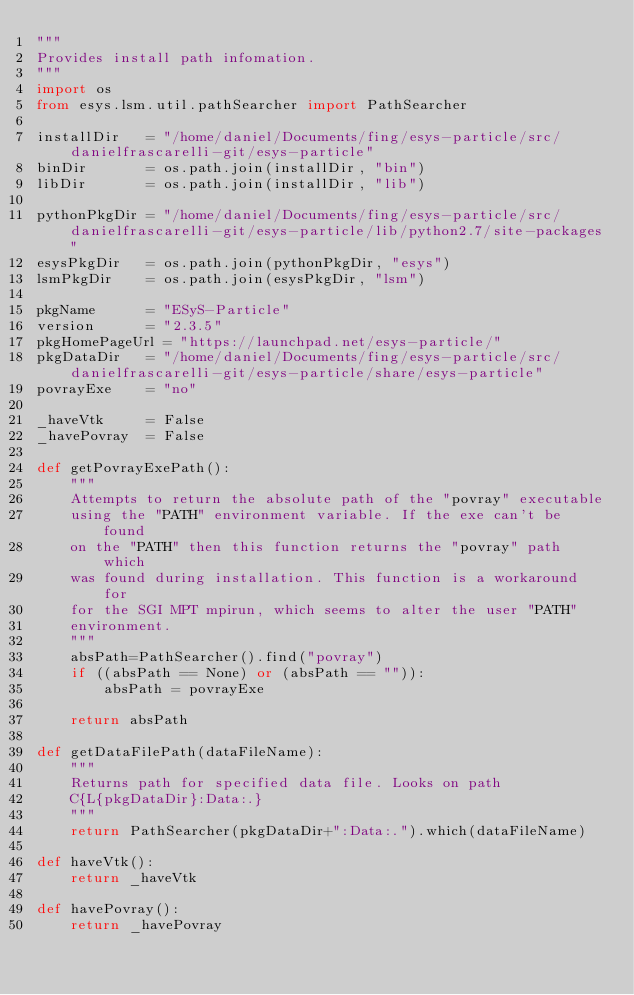<code> <loc_0><loc_0><loc_500><loc_500><_Python_>"""
Provides install path infomation.
"""
import os
from esys.lsm.util.pathSearcher import PathSearcher

installDir   = "/home/daniel/Documents/fing/esys-particle/src/danielfrascarelli-git/esys-particle"
binDir       = os.path.join(installDir, "bin")
libDir       = os.path.join(installDir, "lib")

pythonPkgDir = "/home/daniel/Documents/fing/esys-particle/src/danielfrascarelli-git/esys-particle/lib/python2.7/site-packages"
esysPkgDir   = os.path.join(pythonPkgDir, "esys")
lsmPkgDir    = os.path.join(esysPkgDir, "lsm")

pkgName      = "ESyS-Particle"
version      = "2.3.5"
pkgHomePageUrl = "https://launchpad.net/esys-particle/"
pkgDataDir   = "/home/daniel/Documents/fing/esys-particle/src/danielfrascarelli-git/esys-particle/share/esys-particle"
povrayExe    = "no"

_haveVtk     = False
_havePovray  = False

def getPovrayExePath():
    """
    Attempts to return the absolute path of the "povray" executable
    using the "PATH" environment variable. If the exe can't be found
    on the "PATH" then this function returns the "povray" path which
    was found during installation. This function is a workaround for
    for the SGI MPT mpirun, which seems to alter the user "PATH"
    environment.
    """
    absPath=PathSearcher().find("povray")
    if ((absPath == None) or (absPath == "")):
        absPath = povrayExe

    return absPath

def getDataFilePath(dataFileName):
    """
    Returns path for specified data file. Looks on path
    C{L{pkgDataDir}:Data:.}
    """
    return PathSearcher(pkgDataDir+":Data:.").which(dataFileName)

def haveVtk():
    return _haveVtk

def havePovray():
    return _havePovray

</code> 